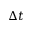<formula> <loc_0><loc_0><loc_500><loc_500>\Delta t</formula> 